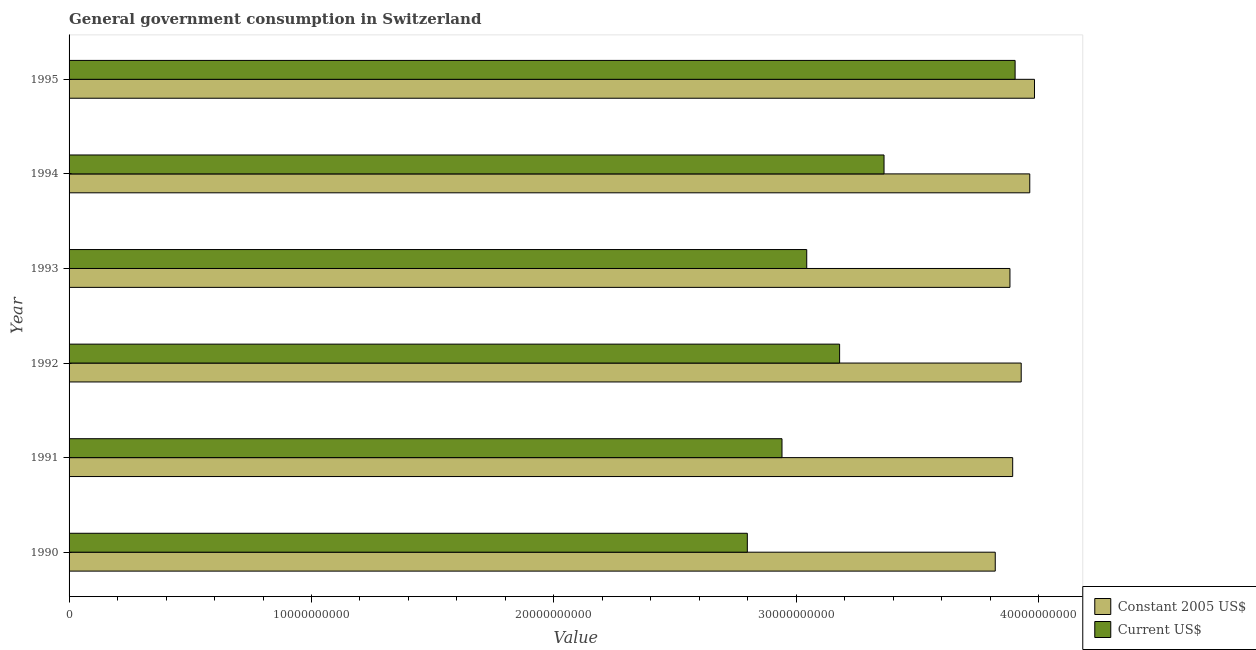How many different coloured bars are there?
Your answer should be compact. 2. How many groups of bars are there?
Give a very brief answer. 6. Are the number of bars on each tick of the Y-axis equal?
Make the answer very short. Yes. How many bars are there on the 1st tick from the top?
Keep it short and to the point. 2. What is the label of the 4th group of bars from the top?
Ensure brevity in your answer.  1992. In how many cases, is the number of bars for a given year not equal to the number of legend labels?
Your answer should be very brief. 0. What is the value consumed in constant 2005 us$ in 1990?
Offer a very short reply. 3.82e+1. Across all years, what is the maximum value consumed in current us$?
Provide a succinct answer. 3.90e+1. Across all years, what is the minimum value consumed in current us$?
Keep it short and to the point. 2.80e+1. In which year was the value consumed in current us$ maximum?
Your response must be concise. 1995. In which year was the value consumed in current us$ minimum?
Ensure brevity in your answer.  1990. What is the total value consumed in current us$ in the graph?
Give a very brief answer. 1.92e+11. What is the difference between the value consumed in current us$ in 1994 and that in 1995?
Offer a very short reply. -5.41e+09. What is the difference between the value consumed in constant 2005 us$ in 1993 and the value consumed in current us$ in 1995?
Keep it short and to the point. -2.12e+08. What is the average value consumed in current us$ per year?
Provide a succinct answer. 3.20e+1. In the year 1991, what is the difference between the value consumed in constant 2005 us$ and value consumed in current us$?
Ensure brevity in your answer.  9.52e+09. Is the value consumed in current us$ in 1991 less than that in 1992?
Your answer should be compact. Yes. Is the difference between the value consumed in current us$ in 1991 and 1995 greater than the difference between the value consumed in constant 2005 us$ in 1991 and 1995?
Make the answer very short. No. What is the difference between the highest and the second highest value consumed in constant 2005 us$?
Your answer should be very brief. 1.95e+08. What is the difference between the highest and the lowest value consumed in constant 2005 us$?
Make the answer very short. 1.62e+09. What does the 2nd bar from the top in 1991 represents?
Your response must be concise. Constant 2005 US$. What does the 2nd bar from the bottom in 1990 represents?
Keep it short and to the point. Current US$. How many years are there in the graph?
Provide a succinct answer. 6. How many legend labels are there?
Your answer should be very brief. 2. What is the title of the graph?
Give a very brief answer. General government consumption in Switzerland. What is the label or title of the X-axis?
Your answer should be very brief. Value. What is the label or title of the Y-axis?
Offer a terse response. Year. What is the Value of Constant 2005 US$ in 1990?
Provide a short and direct response. 3.82e+1. What is the Value of Current US$ in 1990?
Offer a very short reply. 2.80e+1. What is the Value in Constant 2005 US$ in 1991?
Offer a terse response. 3.89e+1. What is the Value of Current US$ in 1991?
Keep it short and to the point. 2.94e+1. What is the Value in Constant 2005 US$ in 1992?
Offer a very short reply. 3.93e+1. What is the Value in Current US$ in 1992?
Your answer should be very brief. 3.18e+1. What is the Value of Constant 2005 US$ in 1993?
Your answer should be compact. 3.88e+1. What is the Value of Current US$ in 1993?
Offer a very short reply. 3.04e+1. What is the Value in Constant 2005 US$ in 1994?
Keep it short and to the point. 3.96e+1. What is the Value in Current US$ in 1994?
Your answer should be very brief. 3.36e+1. What is the Value in Constant 2005 US$ in 1995?
Your answer should be very brief. 3.98e+1. What is the Value in Current US$ in 1995?
Offer a terse response. 3.90e+1. Across all years, what is the maximum Value in Constant 2005 US$?
Provide a short and direct response. 3.98e+1. Across all years, what is the maximum Value in Current US$?
Provide a short and direct response. 3.90e+1. Across all years, what is the minimum Value of Constant 2005 US$?
Provide a succinct answer. 3.82e+1. Across all years, what is the minimum Value in Current US$?
Keep it short and to the point. 2.80e+1. What is the total Value in Constant 2005 US$ in the graph?
Provide a succinct answer. 2.35e+11. What is the total Value in Current US$ in the graph?
Give a very brief answer. 1.92e+11. What is the difference between the Value of Constant 2005 US$ in 1990 and that in 1991?
Provide a succinct answer. -7.19e+08. What is the difference between the Value of Current US$ in 1990 and that in 1991?
Your answer should be compact. -1.43e+09. What is the difference between the Value in Constant 2005 US$ in 1990 and that in 1992?
Offer a terse response. -1.07e+09. What is the difference between the Value of Current US$ in 1990 and that in 1992?
Keep it short and to the point. -3.81e+09. What is the difference between the Value in Constant 2005 US$ in 1990 and that in 1993?
Provide a succinct answer. -6.06e+08. What is the difference between the Value in Current US$ in 1990 and that in 1993?
Offer a very short reply. -2.45e+09. What is the difference between the Value of Constant 2005 US$ in 1990 and that in 1994?
Your answer should be very brief. -1.42e+09. What is the difference between the Value in Current US$ in 1990 and that in 1994?
Give a very brief answer. -5.64e+09. What is the difference between the Value of Constant 2005 US$ in 1990 and that in 1995?
Give a very brief answer. -1.62e+09. What is the difference between the Value in Current US$ in 1990 and that in 1995?
Provide a short and direct response. -1.10e+1. What is the difference between the Value of Constant 2005 US$ in 1991 and that in 1992?
Your response must be concise. -3.51e+08. What is the difference between the Value of Current US$ in 1991 and that in 1992?
Ensure brevity in your answer.  -2.38e+09. What is the difference between the Value of Constant 2005 US$ in 1991 and that in 1993?
Your response must be concise. 1.12e+08. What is the difference between the Value of Current US$ in 1991 and that in 1993?
Your response must be concise. -1.02e+09. What is the difference between the Value of Constant 2005 US$ in 1991 and that in 1994?
Give a very brief answer. -7.05e+08. What is the difference between the Value in Current US$ in 1991 and that in 1994?
Keep it short and to the point. -4.21e+09. What is the difference between the Value of Constant 2005 US$ in 1991 and that in 1995?
Your answer should be compact. -9.00e+08. What is the difference between the Value of Current US$ in 1991 and that in 1995?
Ensure brevity in your answer.  -9.62e+09. What is the difference between the Value of Constant 2005 US$ in 1992 and that in 1993?
Your answer should be compact. 4.64e+08. What is the difference between the Value in Current US$ in 1992 and that in 1993?
Offer a very short reply. 1.36e+09. What is the difference between the Value in Constant 2005 US$ in 1992 and that in 1994?
Keep it short and to the point. -3.53e+08. What is the difference between the Value of Current US$ in 1992 and that in 1994?
Your response must be concise. -1.83e+09. What is the difference between the Value in Constant 2005 US$ in 1992 and that in 1995?
Make the answer very short. -5.48e+08. What is the difference between the Value in Current US$ in 1992 and that in 1995?
Make the answer very short. -7.24e+09. What is the difference between the Value of Constant 2005 US$ in 1993 and that in 1994?
Give a very brief answer. -8.17e+08. What is the difference between the Value in Current US$ in 1993 and that in 1994?
Provide a succinct answer. -3.19e+09. What is the difference between the Value in Constant 2005 US$ in 1993 and that in 1995?
Give a very brief answer. -1.01e+09. What is the difference between the Value of Current US$ in 1993 and that in 1995?
Keep it short and to the point. -8.60e+09. What is the difference between the Value of Constant 2005 US$ in 1994 and that in 1995?
Make the answer very short. -1.95e+08. What is the difference between the Value in Current US$ in 1994 and that in 1995?
Give a very brief answer. -5.41e+09. What is the difference between the Value of Constant 2005 US$ in 1990 and the Value of Current US$ in 1991?
Offer a terse response. 8.80e+09. What is the difference between the Value of Constant 2005 US$ in 1990 and the Value of Current US$ in 1992?
Offer a very short reply. 6.42e+09. What is the difference between the Value in Constant 2005 US$ in 1990 and the Value in Current US$ in 1993?
Provide a short and direct response. 7.78e+09. What is the difference between the Value in Constant 2005 US$ in 1990 and the Value in Current US$ in 1994?
Offer a very short reply. 4.59e+09. What is the difference between the Value in Constant 2005 US$ in 1990 and the Value in Current US$ in 1995?
Your response must be concise. -8.19e+08. What is the difference between the Value in Constant 2005 US$ in 1991 and the Value in Current US$ in 1992?
Your answer should be very brief. 7.14e+09. What is the difference between the Value of Constant 2005 US$ in 1991 and the Value of Current US$ in 1993?
Offer a very short reply. 8.50e+09. What is the difference between the Value of Constant 2005 US$ in 1991 and the Value of Current US$ in 1994?
Your response must be concise. 5.31e+09. What is the difference between the Value of Constant 2005 US$ in 1991 and the Value of Current US$ in 1995?
Make the answer very short. -9.99e+07. What is the difference between the Value in Constant 2005 US$ in 1992 and the Value in Current US$ in 1993?
Provide a short and direct response. 8.85e+09. What is the difference between the Value of Constant 2005 US$ in 1992 and the Value of Current US$ in 1994?
Your answer should be very brief. 5.66e+09. What is the difference between the Value in Constant 2005 US$ in 1992 and the Value in Current US$ in 1995?
Provide a short and direct response. 2.51e+08. What is the difference between the Value in Constant 2005 US$ in 1993 and the Value in Current US$ in 1994?
Offer a terse response. 5.19e+09. What is the difference between the Value of Constant 2005 US$ in 1993 and the Value of Current US$ in 1995?
Offer a terse response. -2.12e+08. What is the difference between the Value in Constant 2005 US$ in 1994 and the Value in Current US$ in 1995?
Make the answer very short. 6.05e+08. What is the average Value in Constant 2005 US$ per year?
Offer a very short reply. 3.91e+1. What is the average Value in Current US$ per year?
Your response must be concise. 3.20e+1. In the year 1990, what is the difference between the Value in Constant 2005 US$ and Value in Current US$?
Offer a terse response. 1.02e+1. In the year 1991, what is the difference between the Value in Constant 2005 US$ and Value in Current US$?
Your answer should be compact. 9.52e+09. In the year 1992, what is the difference between the Value in Constant 2005 US$ and Value in Current US$?
Your answer should be compact. 7.49e+09. In the year 1993, what is the difference between the Value of Constant 2005 US$ and Value of Current US$?
Ensure brevity in your answer.  8.38e+09. In the year 1994, what is the difference between the Value of Constant 2005 US$ and Value of Current US$?
Ensure brevity in your answer.  6.01e+09. In the year 1995, what is the difference between the Value in Constant 2005 US$ and Value in Current US$?
Make the answer very short. 8.00e+08. What is the ratio of the Value of Constant 2005 US$ in 1990 to that in 1991?
Offer a terse response. 0.98. What is the ratio of the Value of Current US$ in 1990 to that in 1991?
Provide a short and direct response. 0.95. What is the ratio of the Value in Constant 2005 US$ in 1990 to that in 1992?
Offer a very short reply. 0.97. What is the ratio of the Value in Current US$ in 1990 to that in 1992?
Provide a short and direct response. 0.88. What is the ratio of the Value in Constant 2005 US$ in 1990 to that in 1993?
Offer a very short reply. 0.98. What is the ratio of the Value in Current US$ in 1990 to that in 1993?
Make the answer very short. 0.92. What is the ratio of the Value of Constant 2005 US$ in 1990 to that in 1994?
Your answer should be very brief. 0.96. What is the ratio of the Value in Current US$ in 1990 to that in 1994?
Make the answer very short. 0.83. What is the ratio of the Value in Constant 2005 US$ in 1990 to that in 1995?
Your response must be concise. 0.96. What is the ratio of the Value of Current US$ in 1990 to that in 1995?
Keep it short and to the point. 0.72. What is the ratio of the Value in Current US$ in 1991 to that in 1992?
Make the answer very short. 0.93. What is the ratio of the Value in Constant 2005 US$ in 1991 to that in 1993?
Make the answer very short. 1. What is the ratio of the Value of Current US$ in 1991 to that in 1993?
Ensure brevity in your answer.  0.97. What is the ratio of the Value of Constant 2005 US$ in 1991 to that in 1994?
Give a very brief answer. 0.98. What is the ratio of the Value in Current US$ in 1991 to that in 1994?
Your response must be concise. 0.87. What is the ratio of the Value of Constant 2005 US$ in 1991 to that in 1995?
Your answer should be compact. 0.98. What is the ratio of the Value in Current US$ in 1991 to that in 1995?
Your response must be concise. 0.75. What is the ratio of the Value in Constant 2005 US$ in 1992 to that in 1993?
Provide a succinct answer. 1.01. What is the ratio of the Value in Current US$ in 1992 to that in 1993?
Provide a short and direct response. 1.04. What is the ratio of the Value of Constant 2005 US$ in 1992 to that in 1994?
Make the answer very short. 0.99. What is the ratio of the Value in Current US$ in 1992 to that in 1994?
Give a very brief answer. 0.95. What is the ratio of the Value in Constant 2005 US$ in 1992 to that in 1995?
Your answer should be very brief. 0.99. What is the ratio of the Value of Current US$ in 1992 to that in 1995?
Offer a terse response. 0.81. What is the ratio of the Value of Constant 2005 US$ in 1993 to that in 1994?
Your answer should be compact. 0.98. What is the ratio of the Value of Current US$ in 1993 to that in 1994?
Make the answer very short. 0.91. What is the ratio of the Value of Constant 2005 US$ in 1993 to that in 1995?
Ensure brevity in your answer.  0.97. What is the ratio of the Value of Current US$ in 1993 to that in 1995?
Provide a short and direct response. 0.78. What is the ratio of the Value of Current US$ in 1994 to that in 1995?
Keep it short and to the point. 0.86. What is the difference between the highest and the second highest Value in Constant 2005 US$?
Your response must be concise. 1.95e+08. What is the difference between the highest and the second highest Value in Current US$?
Keep it short and to the point. 5.41e+09. What is the difference between the highest and the lowest Value of Constant 2005 US$?
Ensure brevity in your answer.  1.62e+09. What is the difference between the highest and the lowest Value in Current US$?
Keep it short and to the point. 1.10e+1. 